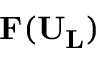<formula> <loc_0><loc_0><loc_500><loc_500>F ( U _ { L } )</formula> 